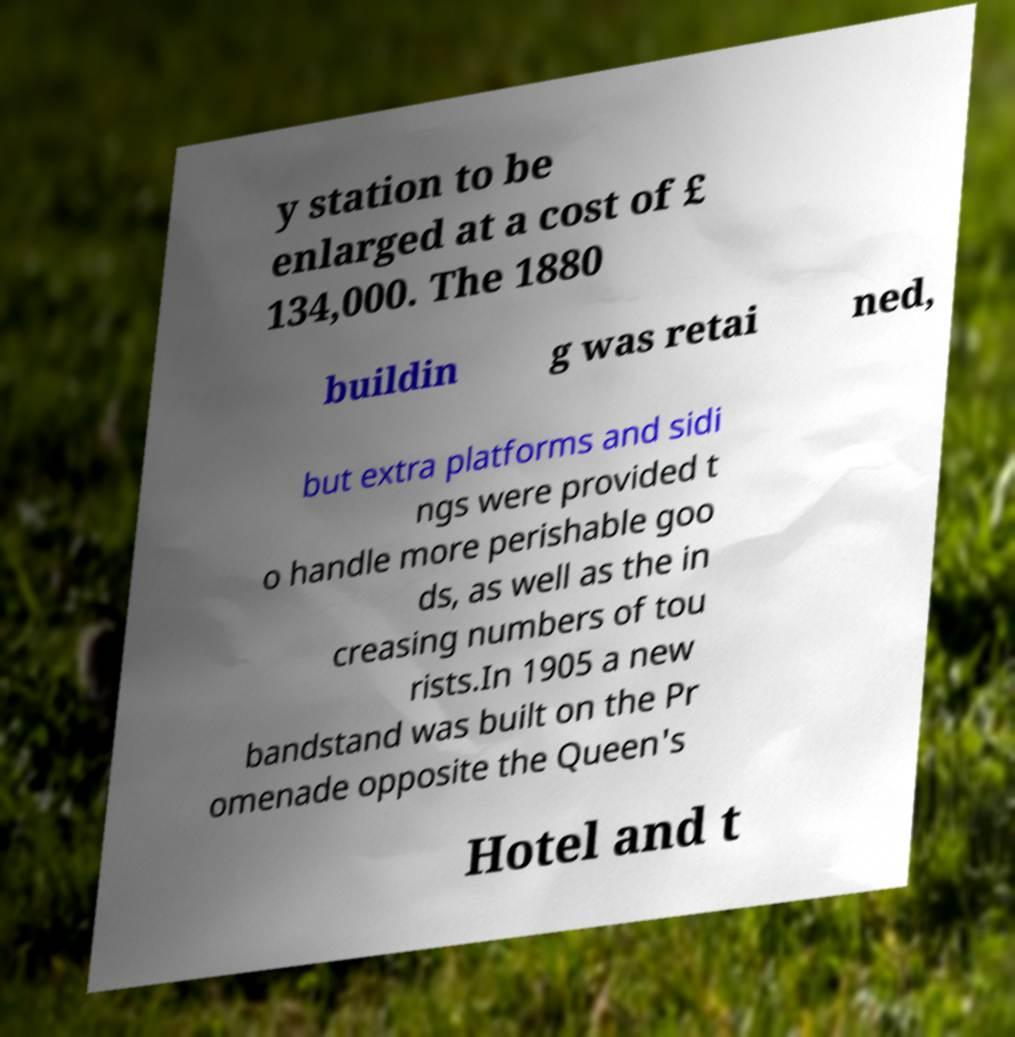Could you assist in decoding the text presented in this image and type it out clearly? y station to be enlarged at a cost of £ 134,000. The 1880 buildin g was retai ned, but extra platforms and sidi ngs were provided t o handle more perishable goo ds, as well as the in creasing numbers of tou rists.In 1905 a new bandstand was built on the Pr omenade opposite the Queen's Hotel and t 